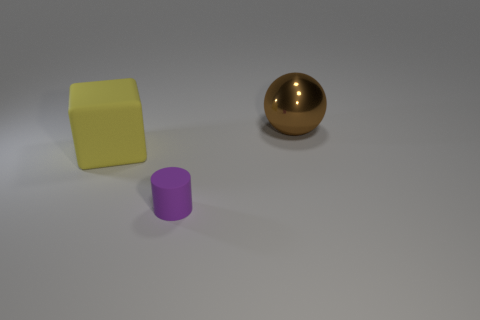What is the color of the large thing that is to the left of the large ball?
Offer a very short reply. Yellow. How big is the metal ball?
Offer a terse response. Large. There is a purple thing; is it the same size as the object behind the large yellow block?
Your answer should be compact. No. The rubber thing that is in front of the large thing that is in front of the large object that is behind the big rubber cube is what color?
Ensure brevity in your answer.  Purple. Do the large thing that is left of the large brown metallic sphere and the purple object have the same material?
Make the answer very short. Yes. How many other objects are there of the same material as the sphere?
Offer a very short reply. 0. There is a yellow block that is the same size as the ball; what is its material?
Offer a terse response. Rubber. Do the matte thing that is right of the big yellow matte thing and the big object that is on the left side of the small object have the same shape?
Your answer should be compact. No. There is another yellow object that is the same size as the metal object; what is its shape?
Give a very brief answer. Cube. Is the large object that is behind the yellow matte block made of the same material as the large object to the left of the tiny purple object?
Keep it short and to the point. No. 